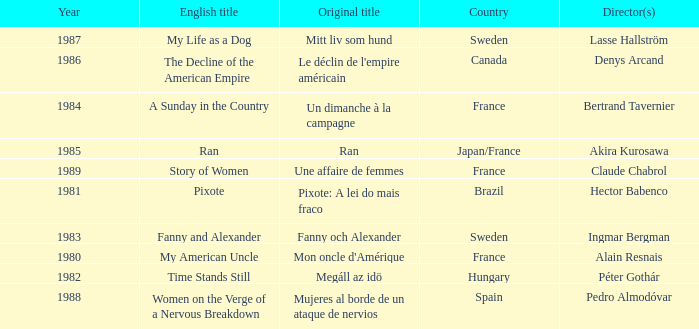Write the full table. {'header': ['Year', 'English title', 'Original title', 'Country', 'Director(s)'], 'rows': [['1987', 'My Life as a Dog', 'Mitt liv som hund', 'Sweden', 'Lasse Hallström'], ['1986', 'The Decline of the American Empire', "Le déclin de l'empire américain", 'Canada', 'Denys Arcand'], ['1984', 'A Sunday in the Country', 'Un dimanche à la campagne', 'France', 'Bertrand Tavernier'], ['1985', 'Ran', 'Ran', 'Japan/France', 'Akira Kurosawa'], ['1989', 'Story of Women', 'Une affaire de femmes', 'France', 'Claude Chabrol'], ['1981', 'Pixote', 'Pixote: A lei do mais fraco', 'Brazil', 'Hector Babenco'], ['1983', 'Fanny and Alexander', 'Fanny och Alexander', 'Sweden', 'Ingmar Bergman'], ['1980', 'My American Uncle', "Mon oncle d'Amérique", 'France', 'Alain Resnais'], ['1982', 'Time Stands Still', 'Megáll az idö', 'Hungary', 'Péter Gothár'], ['1988', 'Women on the Verge of a Nervous Breakdown', 'Mujeres al borde de un ataque de nervios', 'Spain', 'Pedro Almodóvar']]} What was the year of Megáll az Idö? 1982.0. 